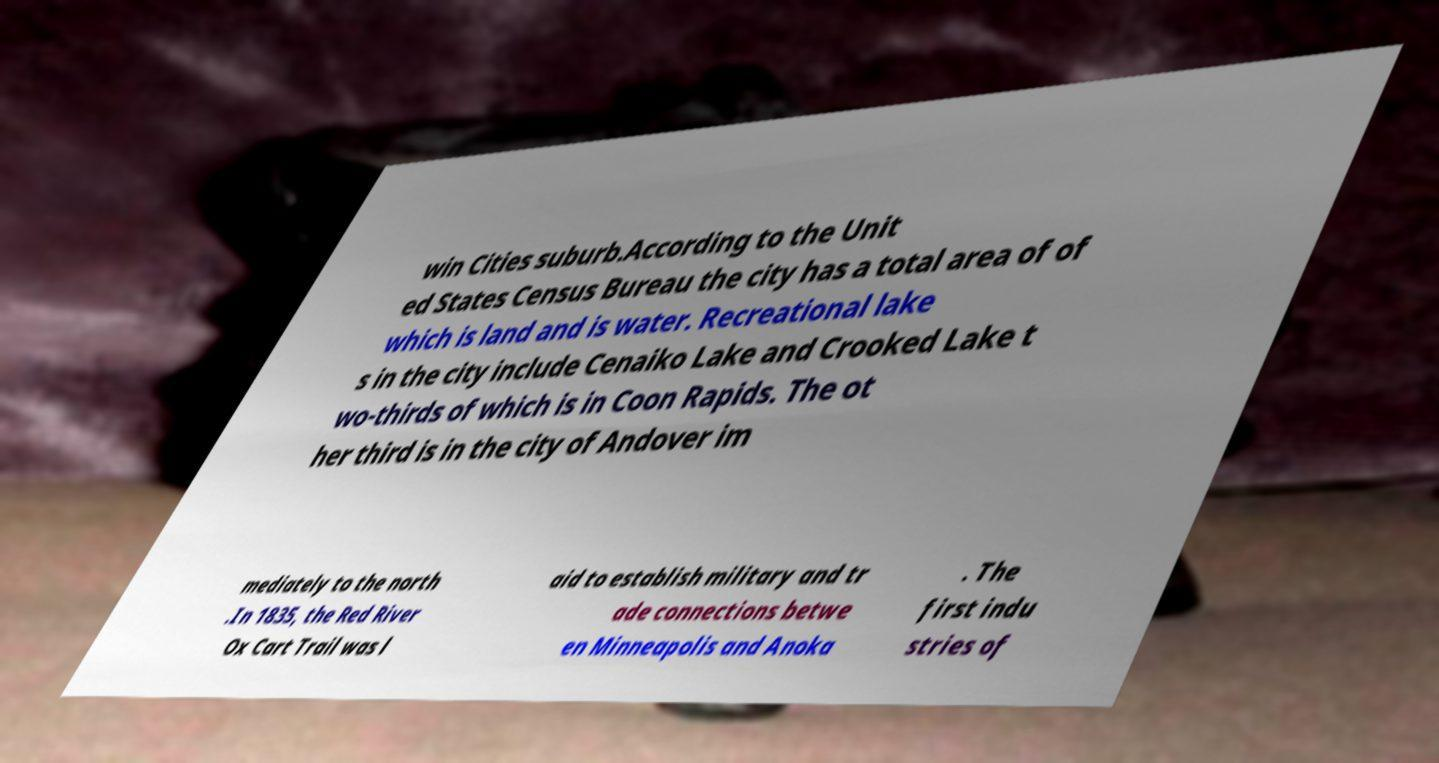For documentation purposes, I need the text within this image transcribed. Could you provide that? win Cities suburb.According to the Unit ed States Census Bureau the city has a total area of of which is land and is water. Recreational lake s in the city include Cenaiko Lake and Crooked Lake t wo-thirds of which is in Coon Rapids. The ot her third is in the city of Andover im mediately to the north .In 1835, the Red River Ox Cart Trail was l aid to establish military and tr ade connections betwe en Minneapolis and Anoka . The first indu stries of 